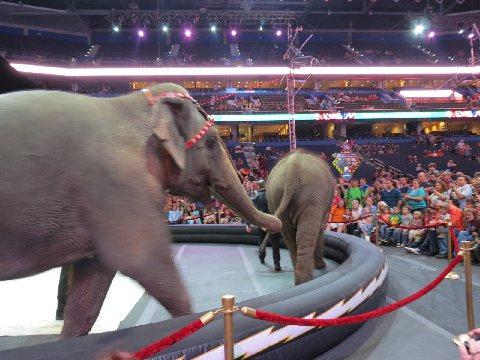Question: what animal is in the ring?
Choices:
A. Lions.
B. Tigers.
C. Horses.
D. Elephants.
Answer with the letter. Answer: D Question: how many animals are there?
Choices:
A. One.
B. Two.
C. Three.
D. Four.
Answer with the letter. Answer: B Question: what kind of event is this?
Choices:
A. Circus.
B. Ballgame.
C. Theater show.
D. Concert.
Answer with the letter. Answer: A Question: why are there ropes?
Choices:
A. To keep people back.
B. To show which way to walk.
C. For decoration.
D. For kids to play with.
Answer with the letter. Answer: A Question: when was this taken?
Choices:
A. During a theater show.
B. During a concert.
C. During a circus performance.
D. During a party.
Answer with the letter. Answer: C 